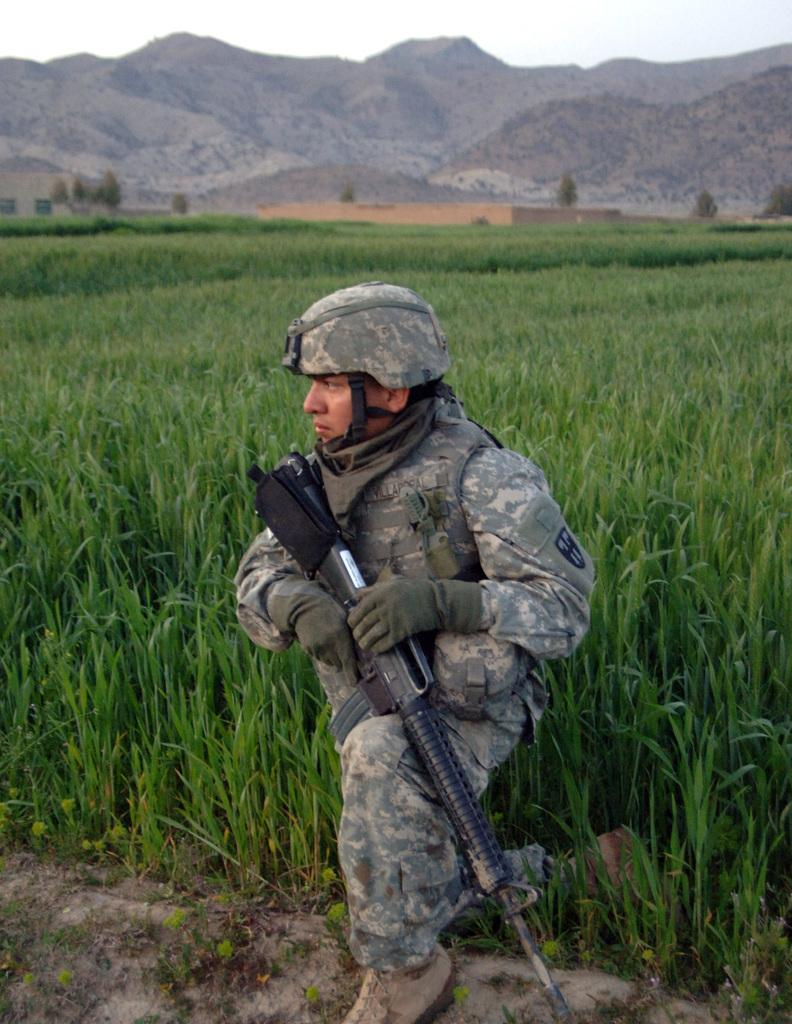What is the main subject of the image? There is a person in the center of the image. What is the person holding in the image? The person is holding a gun. What protective gear is the person wearing? The person is wearing a helmet and gloves. What can be seen in the background of the image? There is sky, hills, trees, and grass visible in the background of the image. What type of lettuce can be seen growing on the person's legs in the image? There is no lettuce or indication of legs in the image; the person is wearing gloves and a helmet. How many chickens are visible in the image? There are no chickens present in the image. 